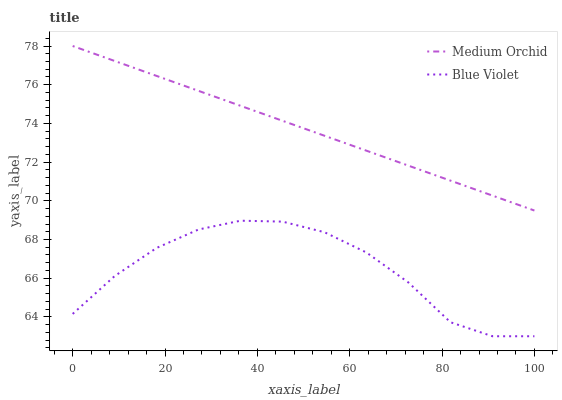Does Blue Violet have the maximum area under the curve?
Answer yes or no. No. Is Blue Violet the smoothest?
Answer yes or no. No. Does Blue Violet have the highest value?
Answer yes or no. No. Is Blue Violet less than Medium Orchid?
Answer yes or no. Yes. Is Medium Orchid greater than Blue Violet?
Answer yes or no. Yes. Does Blue Violet intersect Medium Orchid?
Answer yes or no. No. 